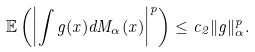Convert formula to latex. <formula><loc_0><loc_0><loc_500><loc_500>\mathbb { E } \left ( \left | \int g ( x ) d M _ { \alpha } ( x ) \right | ^ { p } \right ) \leq c _ { 2 } \| g \| _ { \alpha } ^ { p } .</formula> 